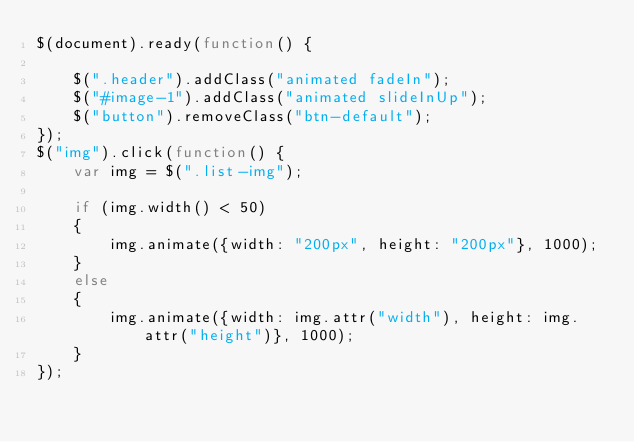Convert code to text. <code><loc_0><loc_0><loc_500><loc_500><_JavaScript_>$(document).ready(function() {

    $(".header").addClass("animated fadeIn");
    $("#image-1").addClass("animated slideInUp");
    $("button").removeClass("btn-default");
});
$("img").click(function() {
    var img = $(".list-img");

    if (img.width() < 50)
    {
        img.animate({width: "200px", height: "200px"}, 1000);
    }
    else 
    {
        img.animate({width: img.attr("width"), height: img.attr("height")}, 1000);
    }
});</code> 